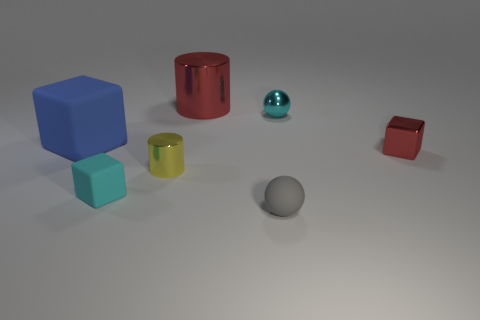Add 3 big red metallic blocks. How many objects exist? 10 Subtract all cylinders. How many objects are left? 5 Subtract 1 gray spheres. How many objects are left? 6 Subtract all tiny cyan matte blocks. Subtract all tiny cylinders. How many objects are left? 5 Add 5 tiny spheres. How many tiny spheres are left? 7 Add 6 gray matte balls. How many gray matte balls exist? 7 